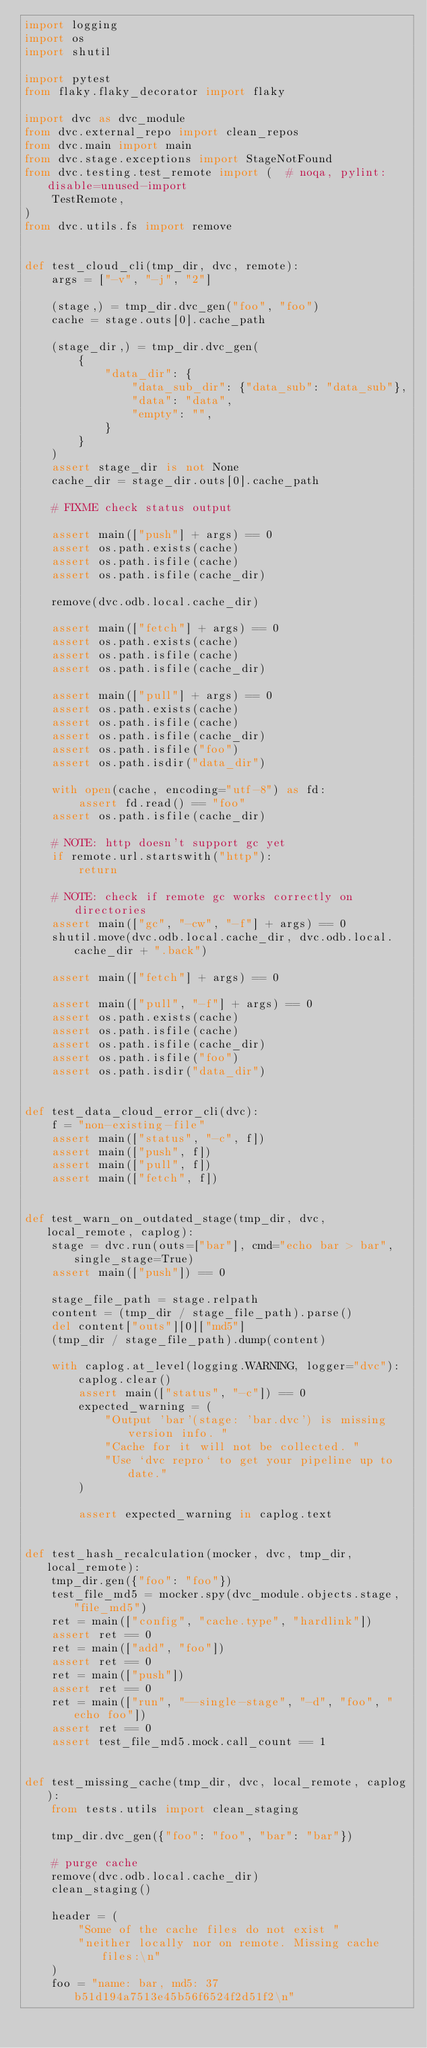Convert code to text. <code><loc_0><loc_0><loc_500><loc_500><_Python_>import logging
import os
import shutil

import pytest
from flaky.flaky_decorator import flaky

import dvc as dvc_module
from dvc.external_repo import clean_repos
from dvc.main import main
from dvc.stage.exceptions import StageNotFound
from dvc.testing.test_remote import (  # noqa, pylint: disable=unused-import
    TestRemote,
)
from dvc.utils.fs import remove


def test_cloud_cli(tmp_dir, dvc, remote):
    args = ["-v", "-j", "2"]

    (stage,) = tmp_dir.dvc_gen("foo", "foo")
    cache = stage.outs[0].cache_path

    (stage_dir,) = tmp_dir.dvc_gen(
        {
            "data_dir": {
                "data_sub_dir": {"data_sub": "data_sub"},
                "data": "data",
                "empty": "",
            }
        }
    )
    assert stage_dir is not None
    cache_dir = stage_dir.outs[0].cache_path

    # FIXME check status output

    assert main(["push"] + args) == 0
    assert os.path.exists(cache)
    assert os.path.isfile(cache)
    assert os.path.isfile(cache_dir)

    remove(dvc.odb.local.cache_dir)

    assert main(["fetch"] + args) == 0
    assert os.path.exists(cache)
    assert os.path.isfile(cache)
    assert os.path.isfile(cache_dir)

    assert main(["pull"] + args) == 0
    assert os.path.exists(cache)
    assert os.path.isfile(cache)
    assert os.path.isfile(cache_dir)
    assert os.path.isfile("foo")
    assert os.path.isdir("data_dir")

    with open(cache, encoding="utf-8") as fd:
        assert fd.read() == "foo"
    assert os.path.isfile(cache_dir)

    # NOTE: http doesn't support gc yet
    if remote.url.startswith("http"):
        return

    # NOTE: check if remote gc works correctly on directories
    assert main(["gc", "-cw", "-f"] + args) == 0
    shutil.move(dvc.odb.local.cache_dir, dvc.odb.local.cache_dir + ".back")

    assert main(["fetch"] + args) == 0

    assert main(["pull", "-f"] + args) == 0
    assert os.path.exists(cache)
    assert os.path.isfile(cache)
    assert os.path.isfile(cache_dir)
    assert os.path.isfile("foo")
    assert os.path.isdir("data_dir")


def test_data_cloud_error_cli(dvc):
    f = "non-existing-file"
    assert main(["status", "-c", f])
    assert main(["push", f])
    assert main(["pull", f])
    assert main(["fetch", f])


def test_warn_on_outdated_stage(tmp_dir, dvc, local_remote, caplog):
    stage = dvc.run(outs=["bar"], cmd="echo bar > bar", single_stage=True)
    assert main(["push"]) == 0

    stage_file_path = stage.relpath
    content = (tmp_dir / stage_file_path).parse()
    del content["outs"][0]["md5"]
    (tmp_dir / stage_file_path).dump(content)

    with caplog.at_level(logging.WARNING, logger="dvc"):
        caplog.clear()
        assert main(["status", "-c"]) == 0
        expected_warning = (
            "Output 'bar'(stage: 'bar.dvc') is missing version info. "
            "Cache for it will not be collected. "
            "Use `dvc repro` to get your pipeline up to date."
        )

        assert expected_warning in caplog.text


def test_hash_recalculation(mocker, dvc, tmp_dir, local_remote):
    tmp_dir.gen({"foo": "foo"})
    test_file_md5 = mocker.spy(dvc_module.objects.stage, "file_md5")
    ret = main(["config", "cache.type", "hardlink"])
    assert ret == 0
    ret = main(["add", "foo"])
    assert ret == 0
    ret = main(["push"])
    assert ret == 0
    ret = main(["run", "--single-stage", "-d", "foo", "echo foo"])
    assert ret == 0
    assert test_file_md5.mock.call_count == 1


def test_missing_cache(tmp_dir, dvc, local_remote, caplog):
    from tests.utils import clean_staging

    tmp_dir.dvc_gen({"foo": "foo", "bar": "bar"})

    # purge cache
    remove(dvc.odb.local.cache_dir)
    clean_staging()

    header = (
        "Some of the cache files do not exist "
        "neither locally nor on remote. Missing cache files:\n"
    )
    foo = "name: bar, md5: 37b51d194a7513e45b56f6524f2d51f2\n"</code> 